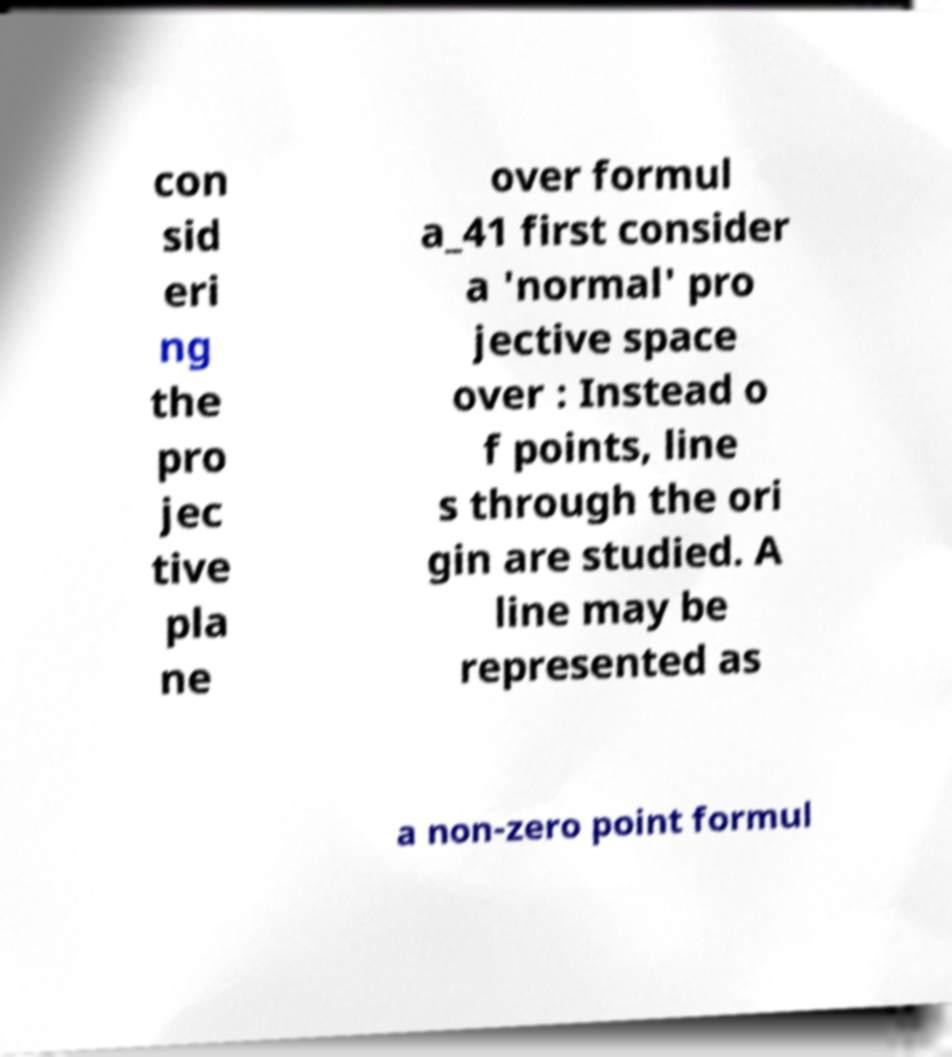Could you extract and type out the text from this image? con sid eri ng the pro jec tive pla ne over formul a_41 first consider a 'normal' pro jective space over : Instead o f points, line s through the ori gin are studied. A line may be represented as a non-zero point formul 